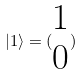<formula> <loc_0><loc_0><loc_500><loc_500>| 1 \rangle = ( \begin{matrix} 1 \\ 0 \end{matrix} )</formula> 